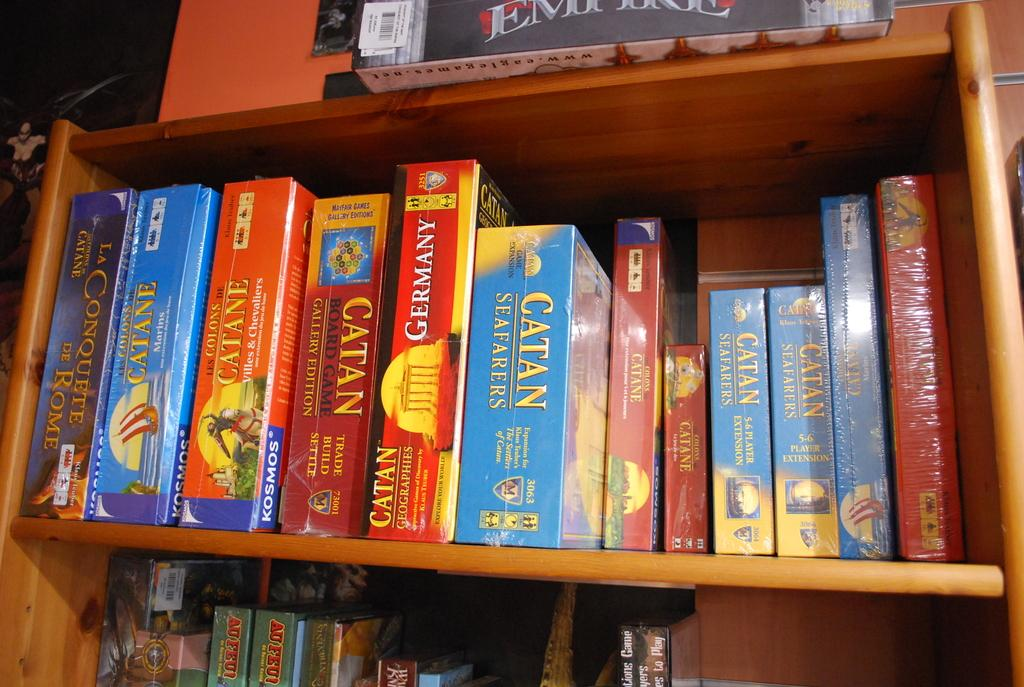<image>
Present a compact description of the photo's key features. A shelf full of Catan board games includes one set in Germany. 